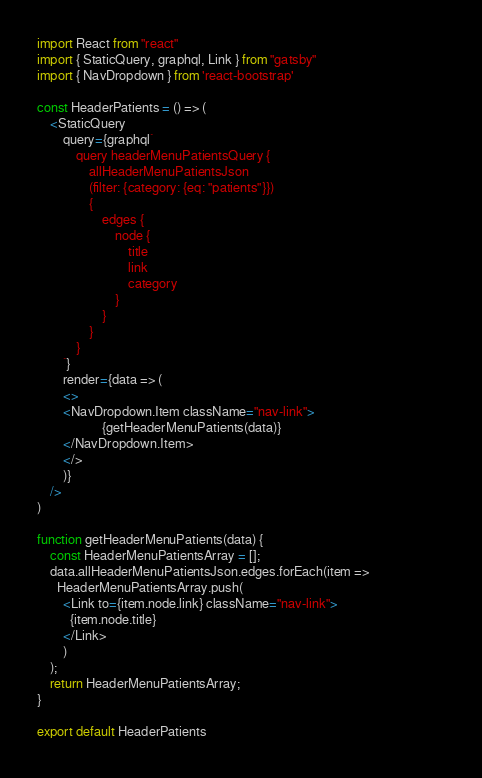Convert code to text. <code><loc_0><loc_0><loc_500><loc_500><_JavaScript_>import React from "react"
import { StaticQuery, graphql, Link } from "gatsby"
import { NavDropdown } from 'react-bootstrap'

const HeaderPatients = () => (
    <StaticQuery
        query={graphql`
            query headerMenuPatientsQuery {
                allHeaderMenuPatientsJson
                (filter: {category: {eq: "patients"}}) 
                {
                    edges {
                        node {
                            title
                            link
                            category
                        }
                    }
                }
            }
        `}
        render={data => (
        <>
        <NavDropdown.Item className="nav-link">                                        
                    {getHeaderMenuPatients(data)}
        </NavDropdown.Item>
        </>
        )}
    />
)

function getHeaderMenuPatients(data) {
    const HeaderMenuPatientsArray = [];
    data.allHeaderMenuPatientsJson.edges.forEach(item =>
      HeaderMenuPatientsArray.push(
        <Link to={item.node.link} className="nav-link">
          {item.node.title}
        </Link>
        )
    );
    return HeaderMenuPatientsArray;
}

export default HeaderPatients


</code> 